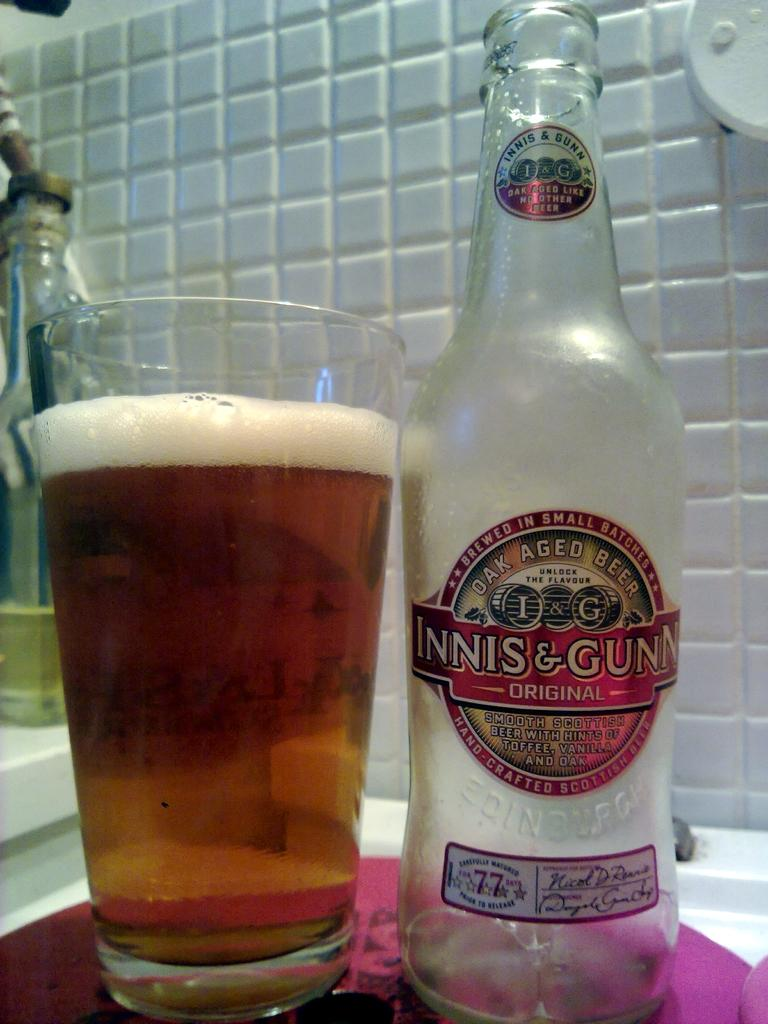<image>
Render a clear and concise summary of the photo. Bottle of Innis & Gunn next to a full cup of beer. 